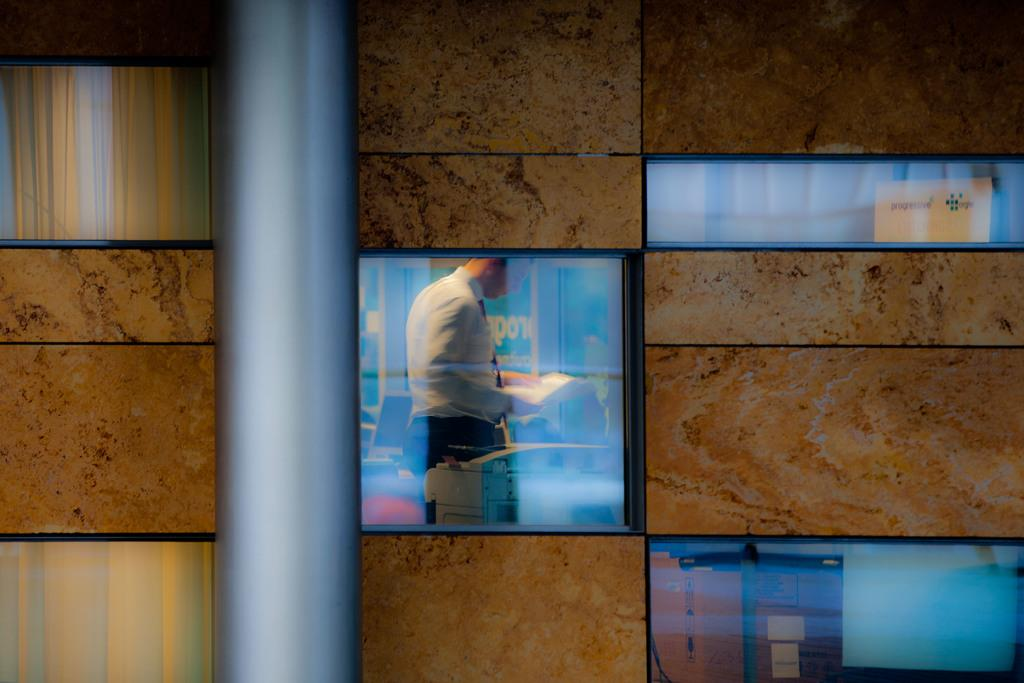What type of structure is visible in the image? There is an architecture in the image. Can you describe the person in the image? A person is standing in the center of the architecture. What is the person holding in the image? The person is holding a paper. What type of machine can be seen operating in the background of the image? There is no machine visible in the image; it only features an architecture with a person holding a paper. 